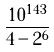Convert formula to latex. <formula><loc_0><loc_0><loc_500><loc_500>\frac { 1 0 ^ { 1 4 3 } } { 4 - 2 ^ { 6 } }</formula> 